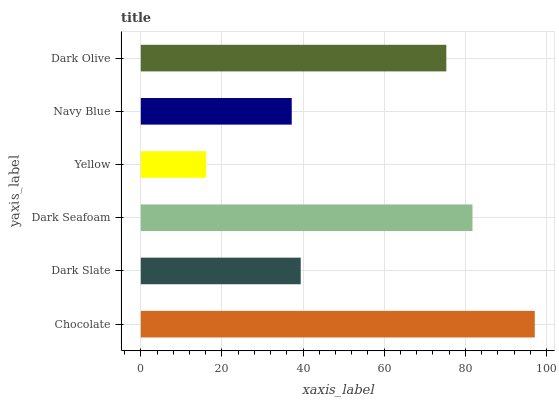Is Yellow the minimum?
Answer yes or no. Yes. Is Chocolate the maximum?
Answer yes or no. Yes. Is Dark Slate the minimum?
Answer yes or no. No. Is Dark Slate the maximum?
Answer yes or no. No. Is Chocolate greater than Dark Slate?
Answer yes or no. Yes. Is Dark Slate less than Chocolate?
Answer yes or no. Yes. Is Dark Slate greater than Chocolate?
Answer yes or no. No. Is Chocolate less than Dark Slate?
Answer yes or no. No. Is Dark Olive the high median?
Answer yes or no. Yes. Is Dark Slate the low median?
Answer yes or no. Yes. Is Yellow the high median?
Answer yes or no. No. Is Chocolate the low median?
Answer yes or no. No. 